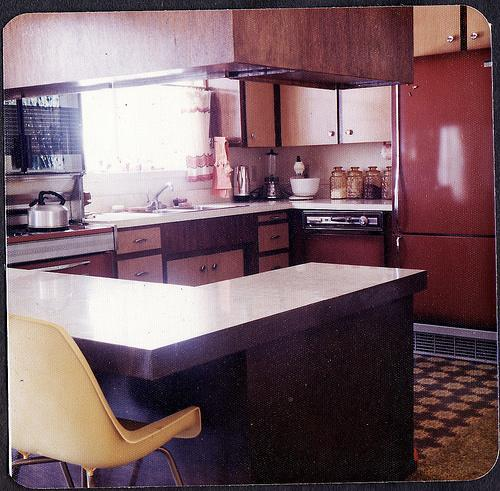What are the jars on the counter?

Choices:
A) gourds
B) cookie jar
C) crocks
D) canisters canisters 